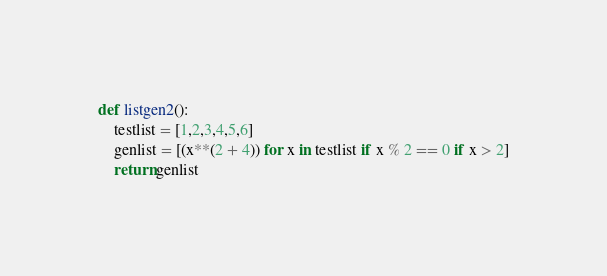<code> <loc_0><loc_0><loc_500><loc_500><_Python_>def listgen2():
    testlist = [1,2,3,4,5,6]
    genlist = [(x**(2 + 4)) for x in testlist if x % 2 == 0 if x > 2]
    return genlist
</code> 